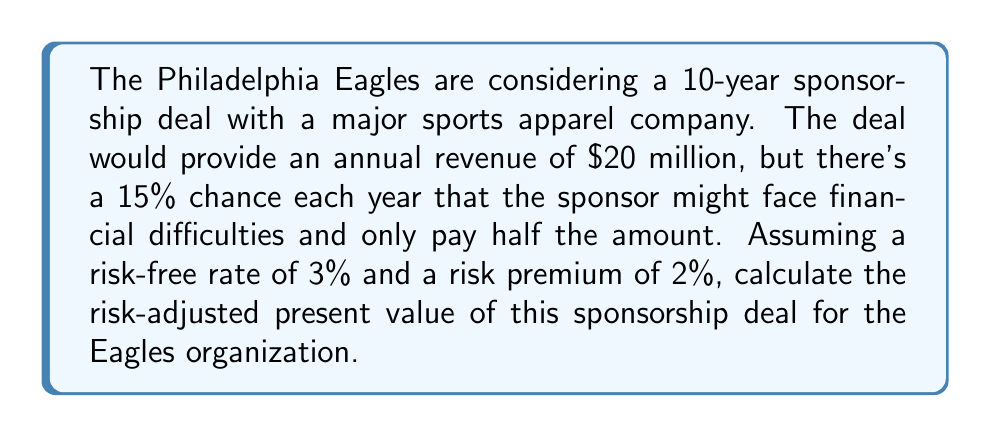Teach me how to tackle this problem. To solve this problem, we need to follow these steps:

1. Calculate the expected annual revenue:
   $E(R) = 0.85 \times \$20M + 0.15 \times \$10M = \$18.5M$

2. Determine the risk-adjusted discount rate:
   $r = r_f + r_p = 3\% + 2\% = 5\%$

3. Calculate the present value of the expected cash flows using the risk-adjusted discount rate:

   $$PV = \sum_{t=1}^{10} \frac{E(R)}{(1+r)^t}$$

   $$PV = \$18.5M \times \sum_{t=1}^{10} \frac{1}{(1.05)^t}$$

4. Use the present value of an annuity formula to simplify the calculation:

   $$PV = \$18.5M \times \frac{1 - (1+0.05)^{-10}}{0.05}$$

5. Solve the equation:
   
   $$PV = \$18.5M \times 7.7217 = \$142.85M$$

The risk-adjusted present value of the sponsorship deal is approximately $142.85 million.
Answer: $142.85 million 